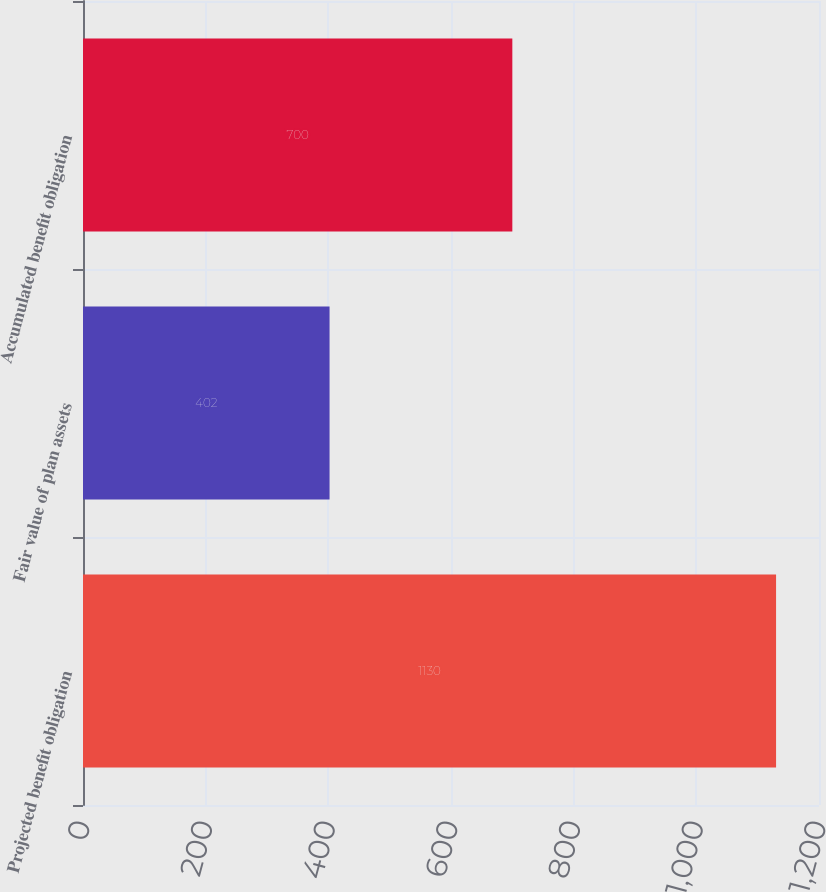Convert chart to OTSL. <chart><loc_0><loc_0><loc_500><loc_500><bar_chart><fcel>Projected benefit obligation<fcel>Fair value of plan assets<fcel>Accumulated benefit obligation<nl><fcel>1130<fcel>402<fcel>700<nl></chart> 